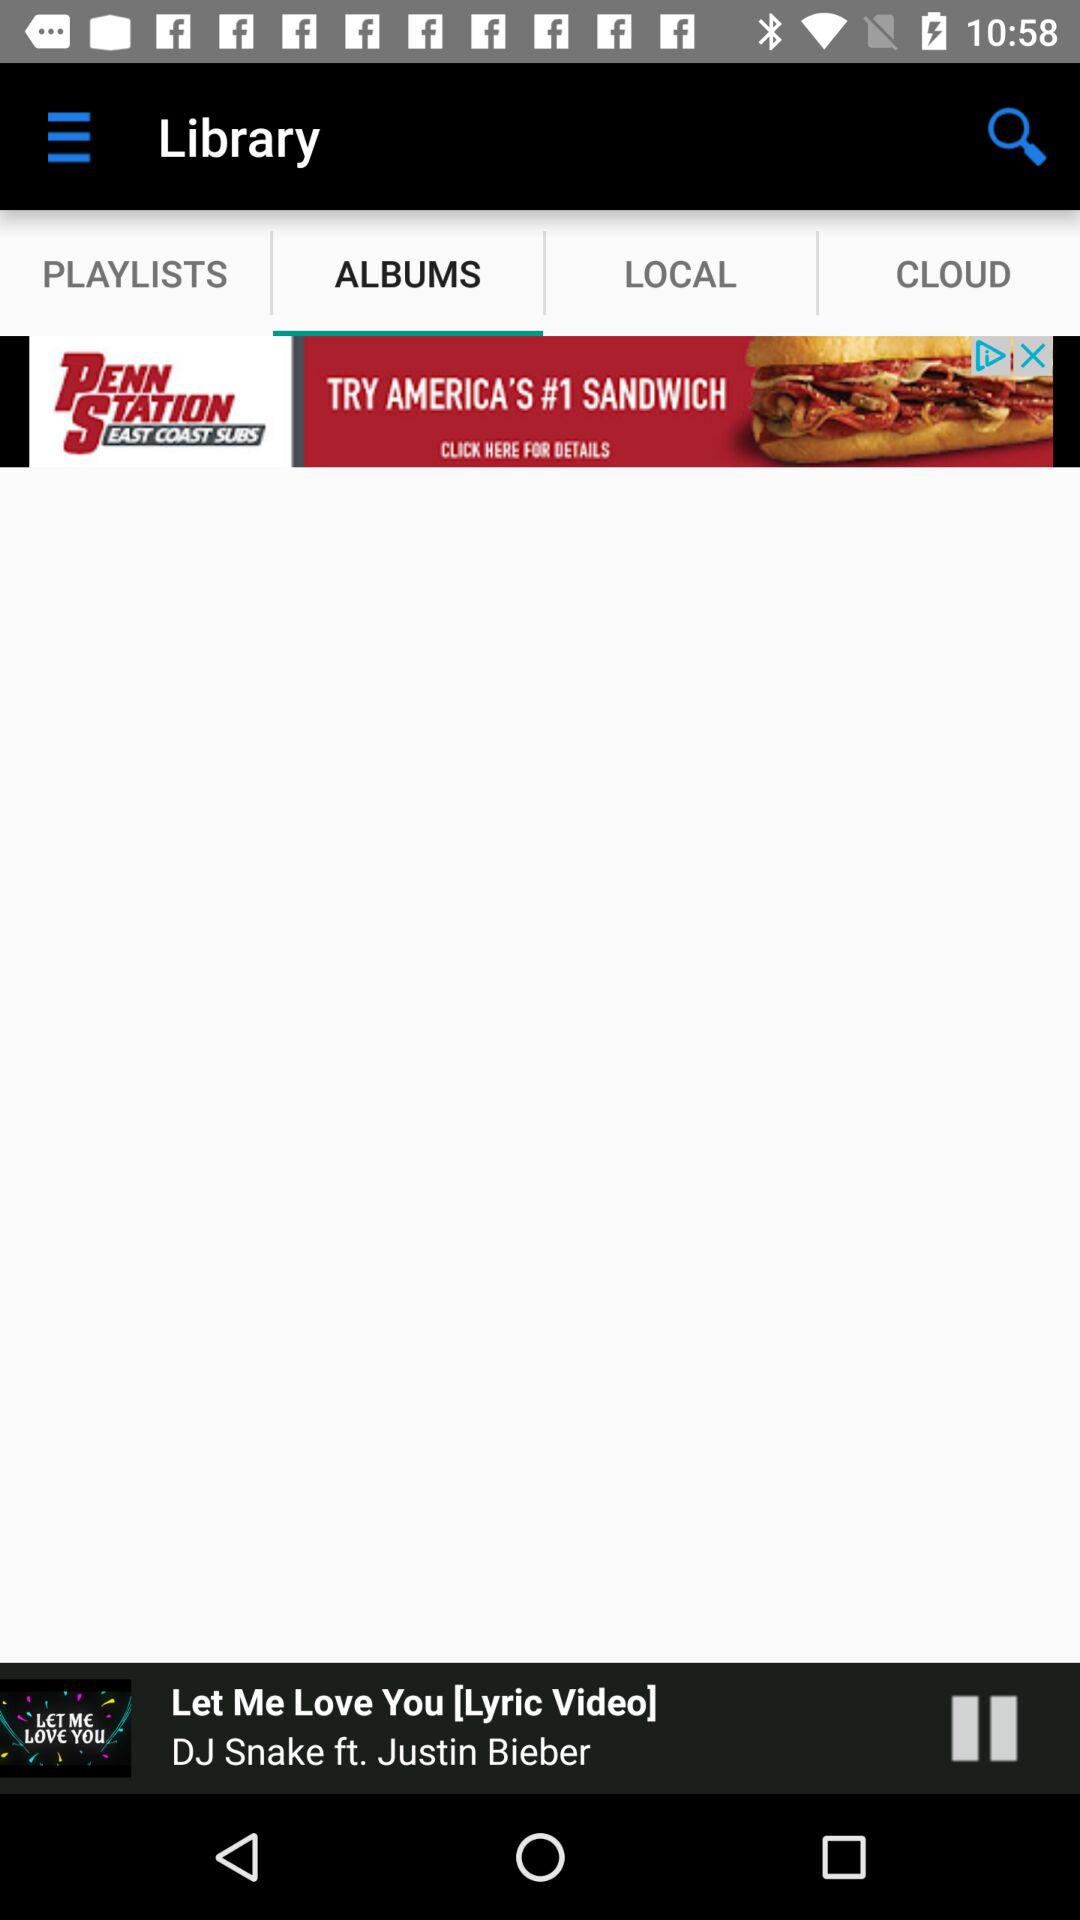Which category of "Library" am I in? You are in the "ALBUMS" category of "Library". 